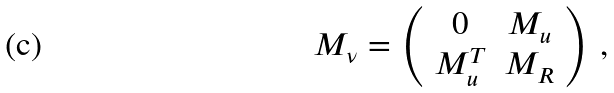<formula> <loc_0><loc_0><loc_500><loc_500>M _ { \nu } = \left ( \begin{array} { c c } 0 & M _ { u } \\ M _ { u } ^ { T } & M _ { R } \\ \end{array} \right ) \, ,</formula> 